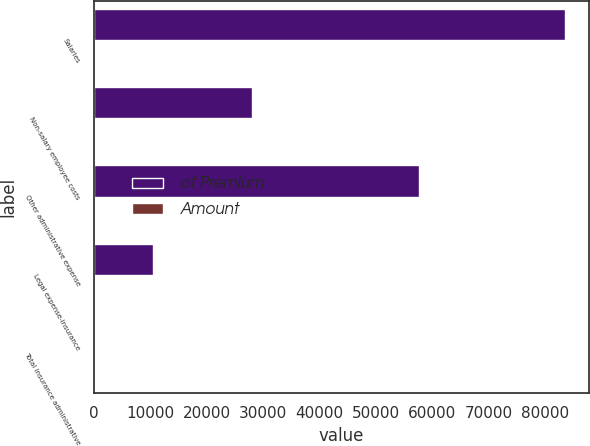<chart> <loc_0><loc_0><loc_500><loc_500><stacked_bar_chart><ecel><fcel>Salaries<fcel>Non-salary employee costs<fcel>Other administrative expense<fcel>Legal expense-insurance<fcel>Total insurance administrative<nl><fcel>of Premium<fcel>83625<fcel>28095<fcel>57717<fcel>10518<fcel>5.6<nl><fcel>Amount<fcel>2.6<fcel>0.9<fcel>1.8<fcel>0.3<fcel>5.6<nl></chart> 